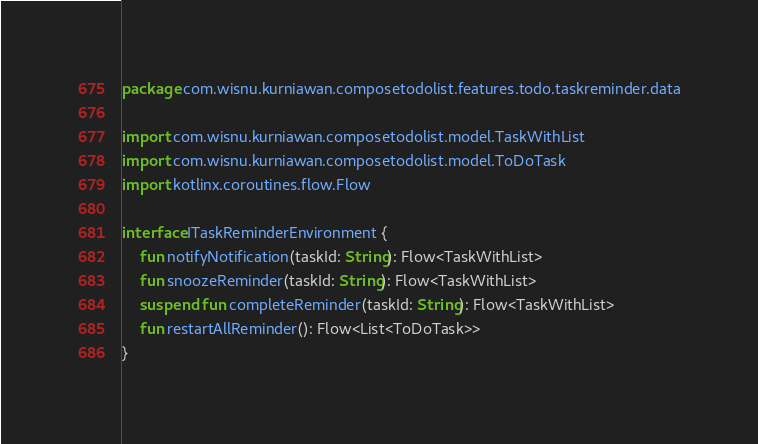<code> <loc_0><loc_0><loc_500><loc_500><_Kotlin_>package com.wisnu.kurniawan.composetodolist.features.todo.taskreminder.data

import com.wisnu.kurniawan.composetodolist.model.TaskWithList
import com.wisnu.kurniawan.composetodolist.model.ToDoTask
import kotlinx.coroutines.flow.Flow

interface ITaskReminderEnvironment {
    fun notifyNotification(taskId: String): Flow<TaskWithList>
    fun snoozeReminder(taskId: String): Flow<TaskWithList>
    suspend fun completeReminder(taskId: String): Flow<TaskWithList>
    fun restartAllReminder(): Flow<List<ToDoTask>>
}
</code> 